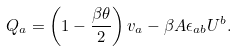Convert formula to latex. <formula><loc_0><loc_0><loc_500><loc_500>Q _ { a } = \left ( 1 - \frac { \beta \theta } { 2 } \right ) v _ { a } - \beta A \epsilon _ { a b } U ^ { b } .</formula> 